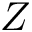Convert formula to latex. <formula><loc_0><loc_0><loc_500><loc_500>Z</formula> 